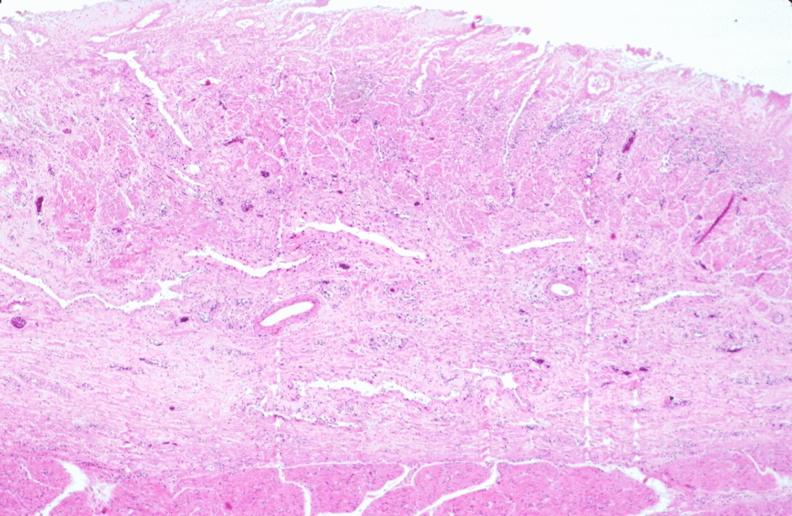what is present?
Answer the question using a single word or phrase. Gastrointestinal 